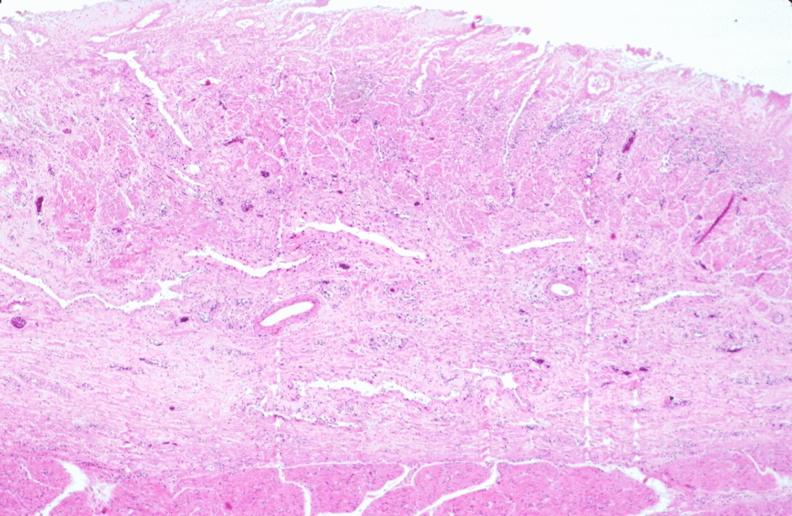what is present?
Answer the question using a single word or phrase. Gastrointestinal 